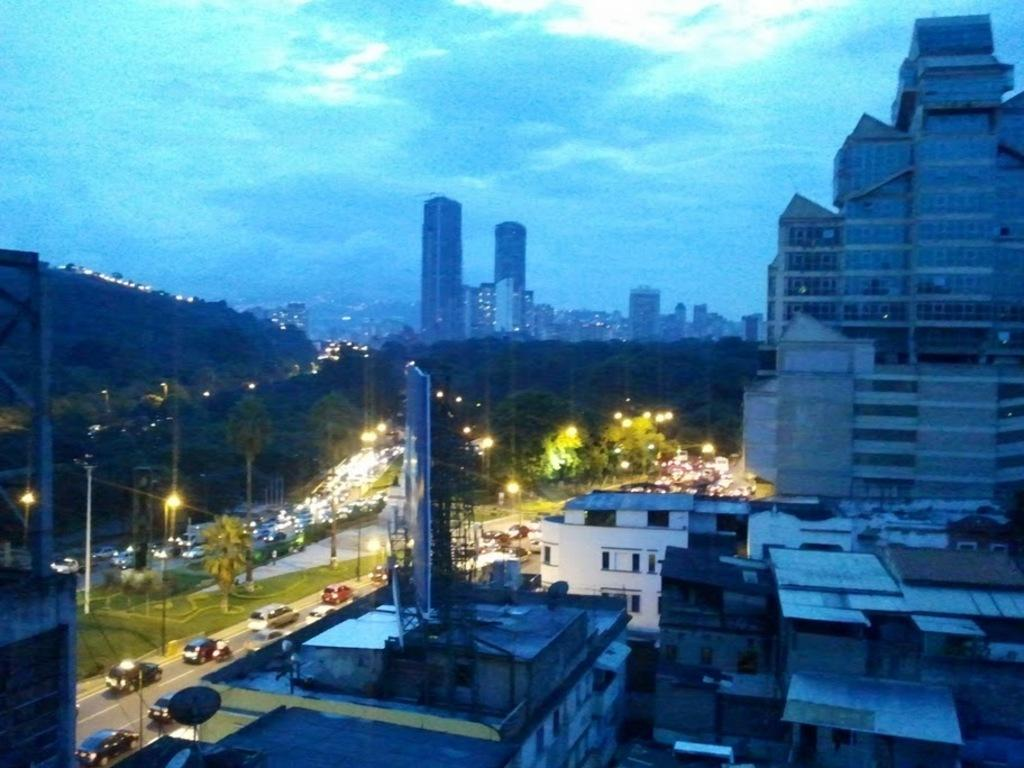What types of structures are visible in the image? There are buildings and houses in the image. What natural elements can be seen in the image? There are trees and mountains in the image. What man-made objects are present in the image? There are light poles and vehicles on the road in the image. What is the color of the sky in the image? The sky is blue at the top of the image. Can you tell if the image was taken during the day or night? The image may have been taken during the night, as there is no indication of sunlight. What type of skirt is being worn by the mountain in the image? There are no skirts present in the image, as the mountain is a natural formation and not a person wearing clothing. What power source is being used by the trees in the image? There is no mention of a power source in the image, as trees are living organisms that do not require electricity or other forms of energy. 